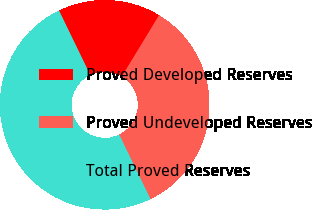Convert chart to OTSL. <chart><loc_0><loc_0><loc_500><loc_500><pie_chart><fcel>Proved Developed Reserves<fcel>Proved Undeveloped Reserves<fcel>Total Proved Reserves<nl><fcel>15.88%<fcel>34.12%<fcel>50.0%<nl></chart> 